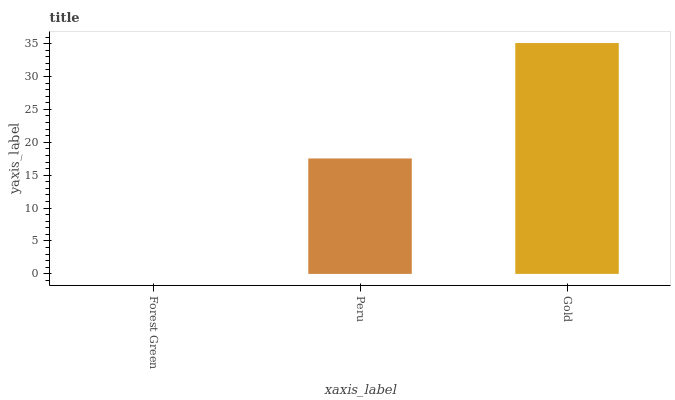Is Forest Green the minimum?
Answer yes or no. Yes. Is Gold the maximum?
Answer yes or no. Yes. Is Peru the minimum?
Answer yes or no. No. Is Peru the maximum?
Answer yes or no. No. Is Peru greater than Forest Green?
Answer yes or no. Yes. Is Forest Green less than Peru?
Answer yes or no. Yes. Is Forest Green greater than Peru?
Answer yes or no. No. Is Peru less than Forest Green?
Answer yes or no. No. Is Peru the high median?
Answer yes or no. Yes. Is Peru the low median?
Answer yes or no. Yes. Is Gold the high median?
Answer yes or no. No. Is Forest Green the low median?
Answer yes or no. No. 